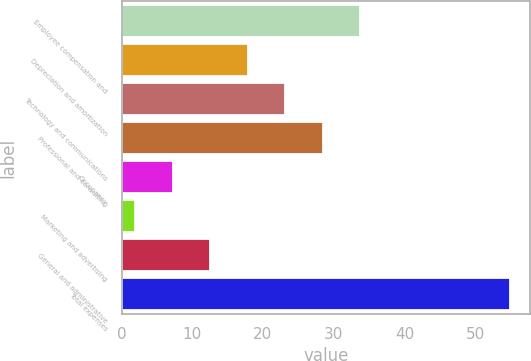<chart> <loc_0><loc_0><loc_500><loc_500><bar_chart><fcel>Employee compensation and<fcel>Depreciation and amortization<fcel>Technology and communications<fcel>Professional and consulting<fcel>Occupancy<fcel>Marketing and advertising<fcel>General and administrative<fcel>Total expenses<nl><fcel>33.76<fcel>17.83<fcel>23.14<fcel>28.45<fcel>7.21<fcel>1.9<fcel>12.52<fcel>55<nl></chart> 